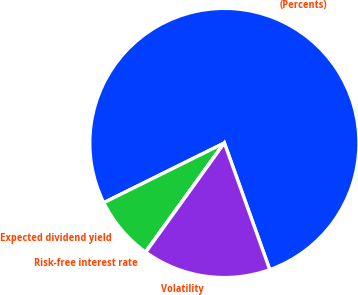Convert chart to OTSL. <chart><loc_0><loc_0><loc_500><loc_500><pie_chart><fcel>(Percents)<fcel>Expected dividend yield<fcel>Risk-free interest rate<fcel>Volatility<nl><fcel>76.85%<fcel>7.72%<fcel>0.04%<fcel>15.4%<nl></chart> 